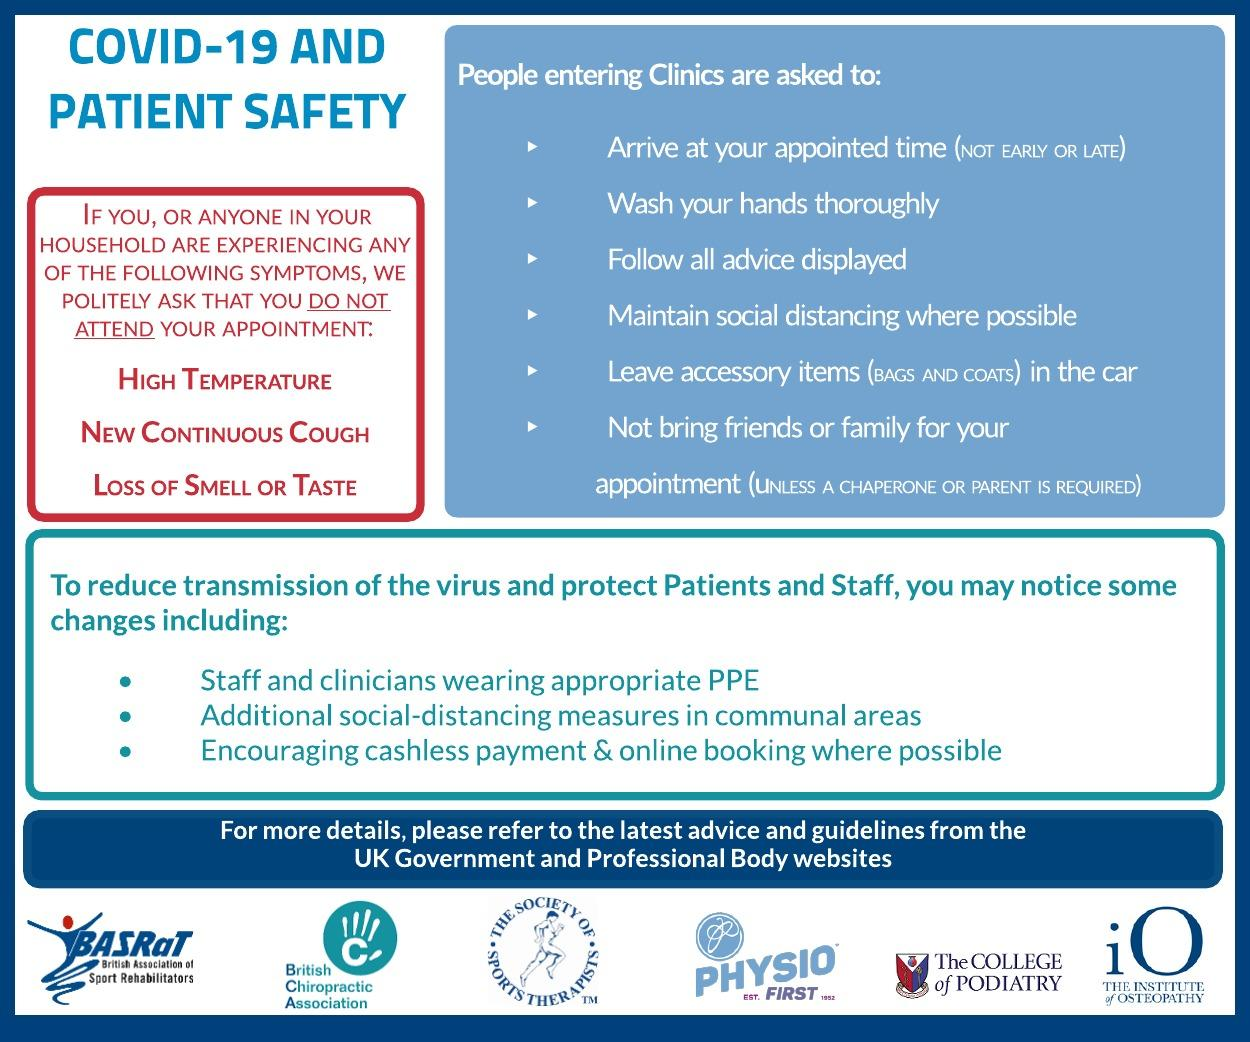Identify some key points in this picture. It is advisable to leave all accessory items in your vehicle before entering the clinic. It is the protective dress code for staff and clinicians to wear Personal Protective Equipment (PPE) to ensure their safety and protection while working in the laboratory. It is not permitted for friends or family members to accompany individuals on appointments. It is encouraged to use cashless payment methods and to make online bookings for payment and reservations. It is not expected that the patients will arrive for their appointment early. 